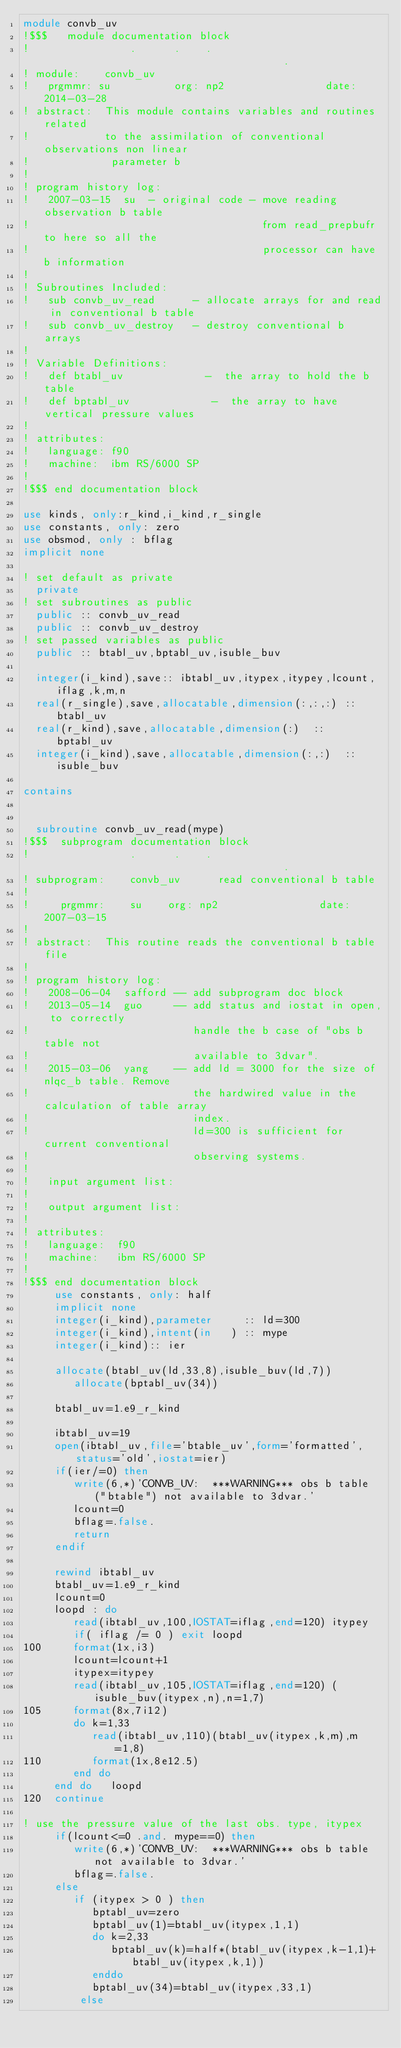<code> <loc_0><loc_0><loc_500><loc_500><_FORTRAN_>module convb_uv
!$$$   module documentation block
!                .      .    .                                       .
! module:    convb_uv
!   prgmmr: su          org: np2                date: 2014-03-28
! abstract:  This module contains variables and routines related
!            to the assimilation of conventional observations non linear 
!             parameter b 
!
! program history log:
!   2007-03-15  su  - original code - move reading observation b table 
!                                     from read_prepbufr to here so all the 
!                                     processor can have b information 
!
! Subroutines Included:
!   sub convb_uv_read      - allocate arrays for and read in conventional b table 
!   sub convb_uv_destroy   - destroy conventional b arrays
!
! Variable Definitions:
!   def btabl_uv             -  the array to hold the b table
!   def bptabl_uv             -  the array to have vertical pressure values
!
! attributes:
!   language: f90
!   machine:  ibm RS/6000 SP
!
!$$$ end documentation block

use kinds, only:r_kind,i_kind,r_single
use constants, only: zero
use obsmod, only : bflag 
implicit none

! set default as private
  private
! set subroutines as public
  public :: convb_uv_read
  public :: convb_uv_destroy
! set passed variables as public
  public :: btabl_uv,bptabl_uv,isuble_buv

  integer(i_kind),save:: ibtabl_uv,itypex,itypey,lcount,iflag,k,m,n
  real(r_single),save,allocatable,dimension(:,:,:) :: btabl_uv
  real(r_kind),save,allocatable,dimension(:)  :: bptabl_uv
  integer(i_kind),save,allocatable,dimension(:,:)  :: isuble_buv

contains


  subroutine convb_uv_read(mype)
!$$$  subprogram documentation block
!                .      .    .                                       .
! subprogram:    convb_uv      read conventional b table 
!
!     prgmmr:    su    org: np2                date: 2007-03-15
!
! abstract:  This routine reads the conventional b table file
!
! program history log:
!   2008-06-04  safford -- add subprogram doc block
!   2013-05-14  guo     -- add status and iostat in open, to correctly
!                          handle the b case of "obs b table not
!                          available to 3dvar".
!   2015-03-06  yang    -- add ld = 3000 for the size of nlqc_b table. Remove
!                          the hardwired value in the calculation of table array
!                          index.
!                          ld=300 is sufficient for current conventional
!                          observing systems.
!
!   input argument list:
!
!   output argument list:
!
! attributes:
!   language:  f90
!   machine:   ibm RS/6000 SP
!
!$$$ end documentation block
     use constants, only: half
     implicit none
     integer(i_kind),parameter     :: ld=300
     integer(i_kind),intent(in   ) :: mype
     integer(i_kind):: ier

     allocate(btabl_uv(ld,33,8),isuble_buv(ld,7))
        allocate(bptabl_uv(34))

     btabl_uv=1.e9_r_kind
      
     ibtabl_uv=19
     open(ibtabl_uv,file='btable_uv',form='formatted',status='old',iostat=ier)
     if(ier/=0) then
        write(6,*)'CONVB_UV:  ***WARNING*** obs b table ("btable") not available to 3dvar.'
        lcount=0
        bflag=.false.
        return
     endif

     rewind ibtabl_uv
     btabl_uv=1.e9_r_kind
     lcount=0
     loopd : do 
        read(ibtabl_uv,100,IOSTAT=iflag,end=120) itypey
        if( iflag /= 0 ) exit loopd
100     format(1x,i3)
        lcount=lcount+1
        itypex=itypey
        read(ibtabl_uv,105,IOSTAT=iflag,end=120) (isuble_buv(itypex,n),n=1,7)
105     format(8x,7i12)
        do k=1,33
           read(ibtabl_uv,110)(btabl_uv(itypex,k,m),m=1,8)
110        format(1x,8e12.5)
        end do
     end do   loopd
120  continue

! use the pressure value of the last obs. type, itypex
     if(lcount<=0 .and. mype==0) then
        write(6,*)'CONVB_UV:  ***WARNING*** obs b table not available to 3dvar.'
        bflag=.false.
     else
        if (itypex > 0 ) then
           bptabl_uv=zero
           bptabl_uv(1)=btabl_uv(itypex,1,1)
           do k=2,33
              bptabl_uv(k)=half*(btabl_uv(itypex,k-1,1)+btabl_uv(itypex,k,1))
           enddo
           bptabl_uv(34)=btabl_uv(itypex,33,1)
         else</code> 